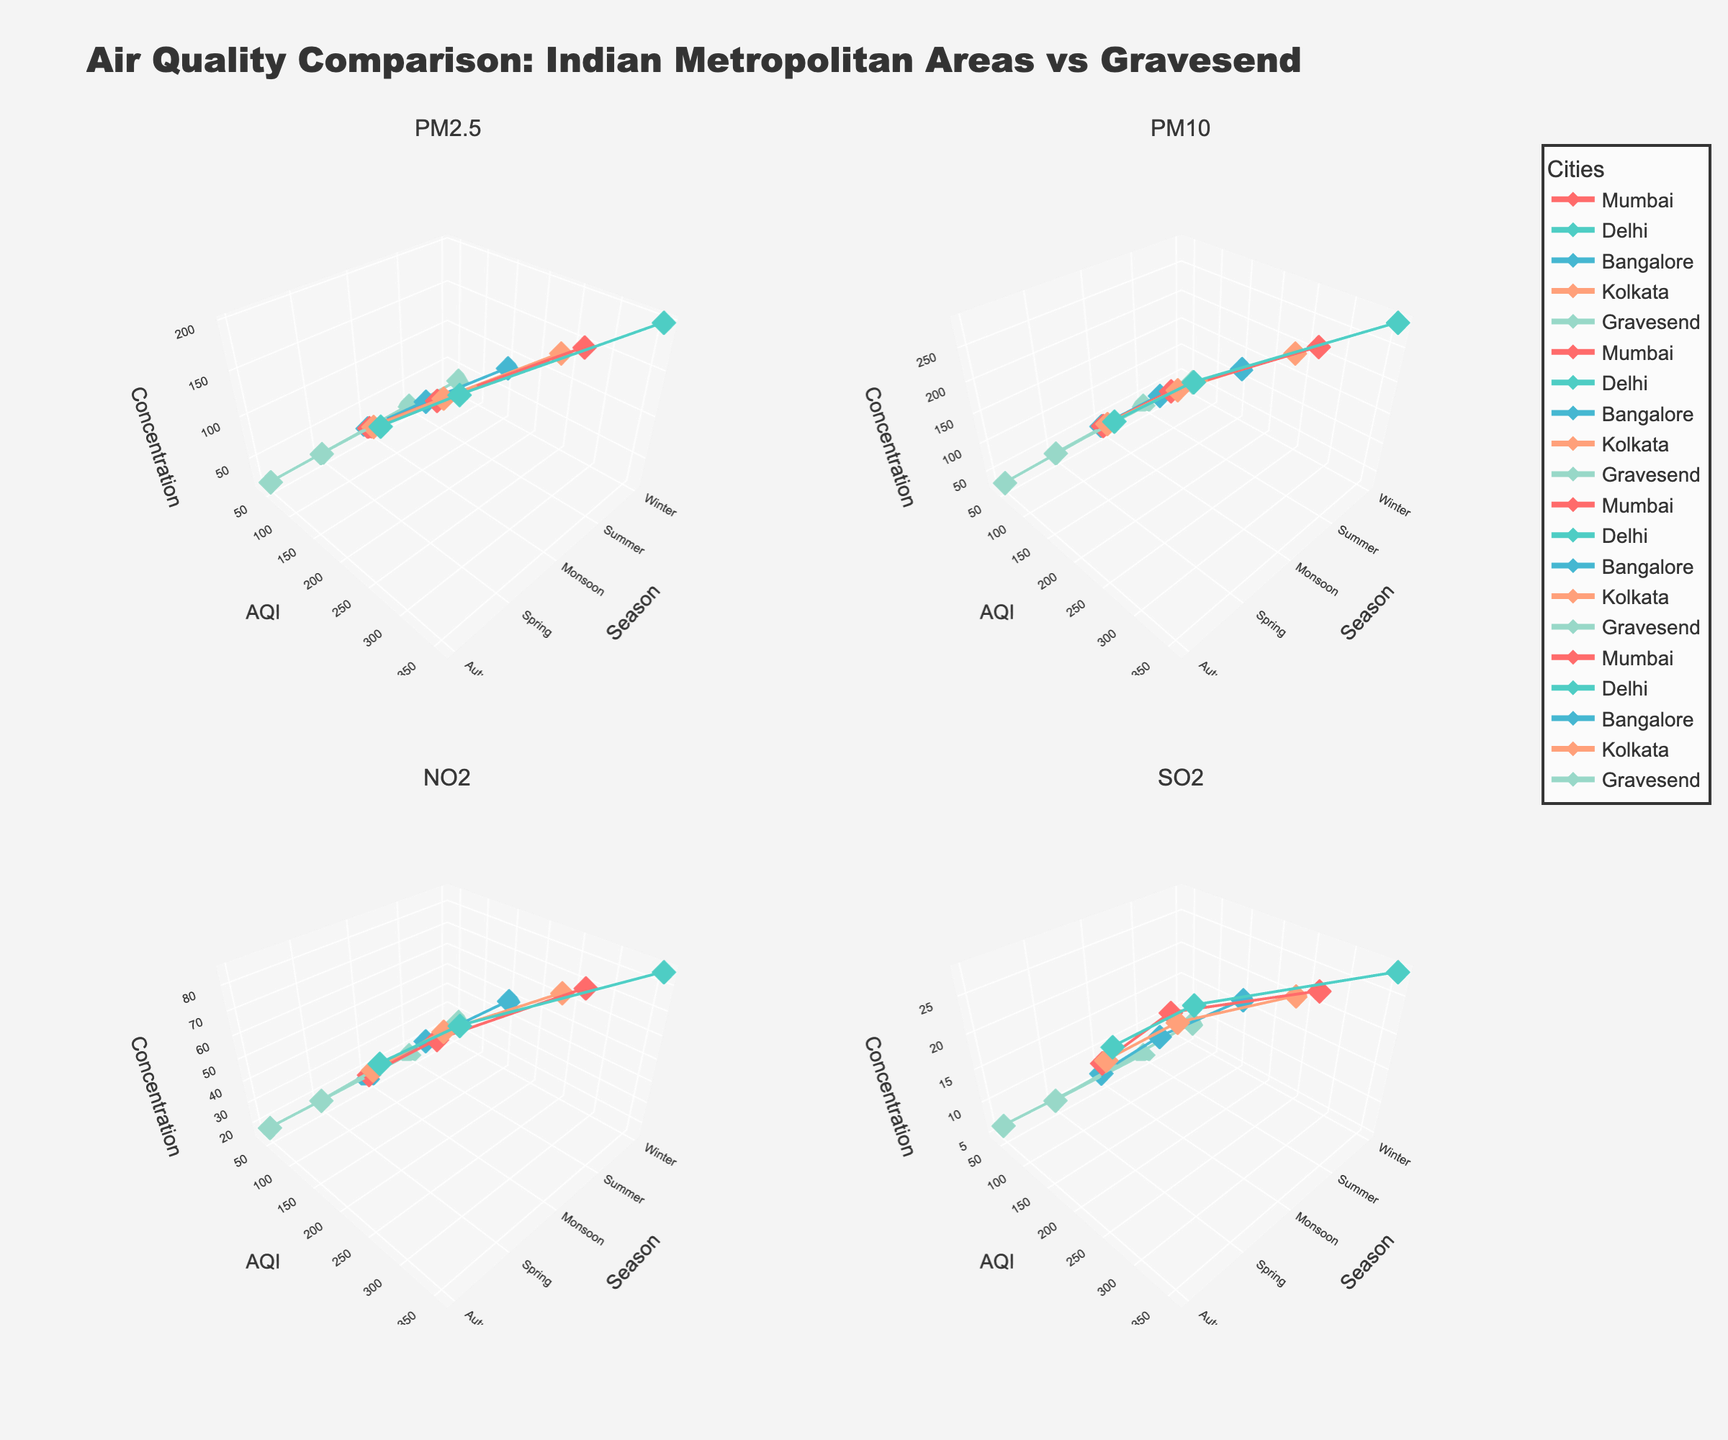Which city has the highest AQI during winter? The figure shows different AQI levels during each season for multiple cities. By looking at the data points (markers) on the plot for winter, Delhi has the highest AQI value, which is significantly higher than that of other cities.
Answer: Delhi Which season shows the lowest AQI for Gravesend? The plot shows the AQI values for Gravesend across different seasons. By examining the data points associated with each season, the summer season has the lowest AQI value.
Answer: Summer Compare the concentration of PM2.5 in Mumbai during summer and monsoon seasons. Which season has a higher concentration? Examine the plot for PM2.5 concentrations for Mumbai. The data points and connecting lines indicate that the concentration of PM2.5 during the summer (48) is higher than during the monsoon season (22).
Answer: Summer What is the average AQI for Bangalore across all seasons? The AQI values for Bangalore across different seasons are: Winter (152), Summer (72), and Monsoon (38). Adding them up results in a total AQI of 262. Dividing this by 3 (the number of seasons) gives an average AQI of approximately 87.
Answer: 87 Which season has the highest concentration of PM10 in Kolkata? The PM10 concentrations in Kolkata can be observed across different seasons. Winter has the highest concentration as indicated by the highest data point.
Answer: Winter Is the concentration of NO2 in Gravesend during Spring higher or lower than in Autumn? Look at the 3D plot for NO2 concentrations. The Spring season shows a NO2 concentration of 18, while the Autumn season shows a concentration of 20. Autumn has a higher concentration.
Answer: Lower Comparing Delhi and Kolkata, which city has a higher AQI during the monsoon season? For the monsoon season, observe the AQI data points for both Delhi and Kolkata. Delhi has an AQI of 68, while Kolkata has an AQI of 52. Delhi has a higher AQI.
Answer: Delhi What is the range of SO2 concentration in Gravesend across all seasons? SO2 concentrations for Gravesend are: Winter (8), Spring (6), Summer (5), and Autumn (7). The range is calculated as the difference between the highest (8) and lowest (5) values, which is 3.
Answer: 3 Which pollutant shows the largest seasonal variation in Bangalore? Compare the range of concentrations of each pollutant for Bangalore across different seasons by subtracting the minimum value from the maximum value. PM2.5 ranges from 20 to 82 (62), PM10 from 35 to 118 (83), NO2 from 15 to 48 (33), and SO2 from 6 to 16 (10). PM10 shows the largest variation.
Answer: PM10 How does the winter AQI of Gravesend compare to the summer AQI of Mumbai? Examine the AQI values in the plot for Gravesend (Winter: 58) and Mumbai (Summer: 95). The AQI in Mumbai during summer is higher than that in Gravesend during winter.
Answer: Lower 